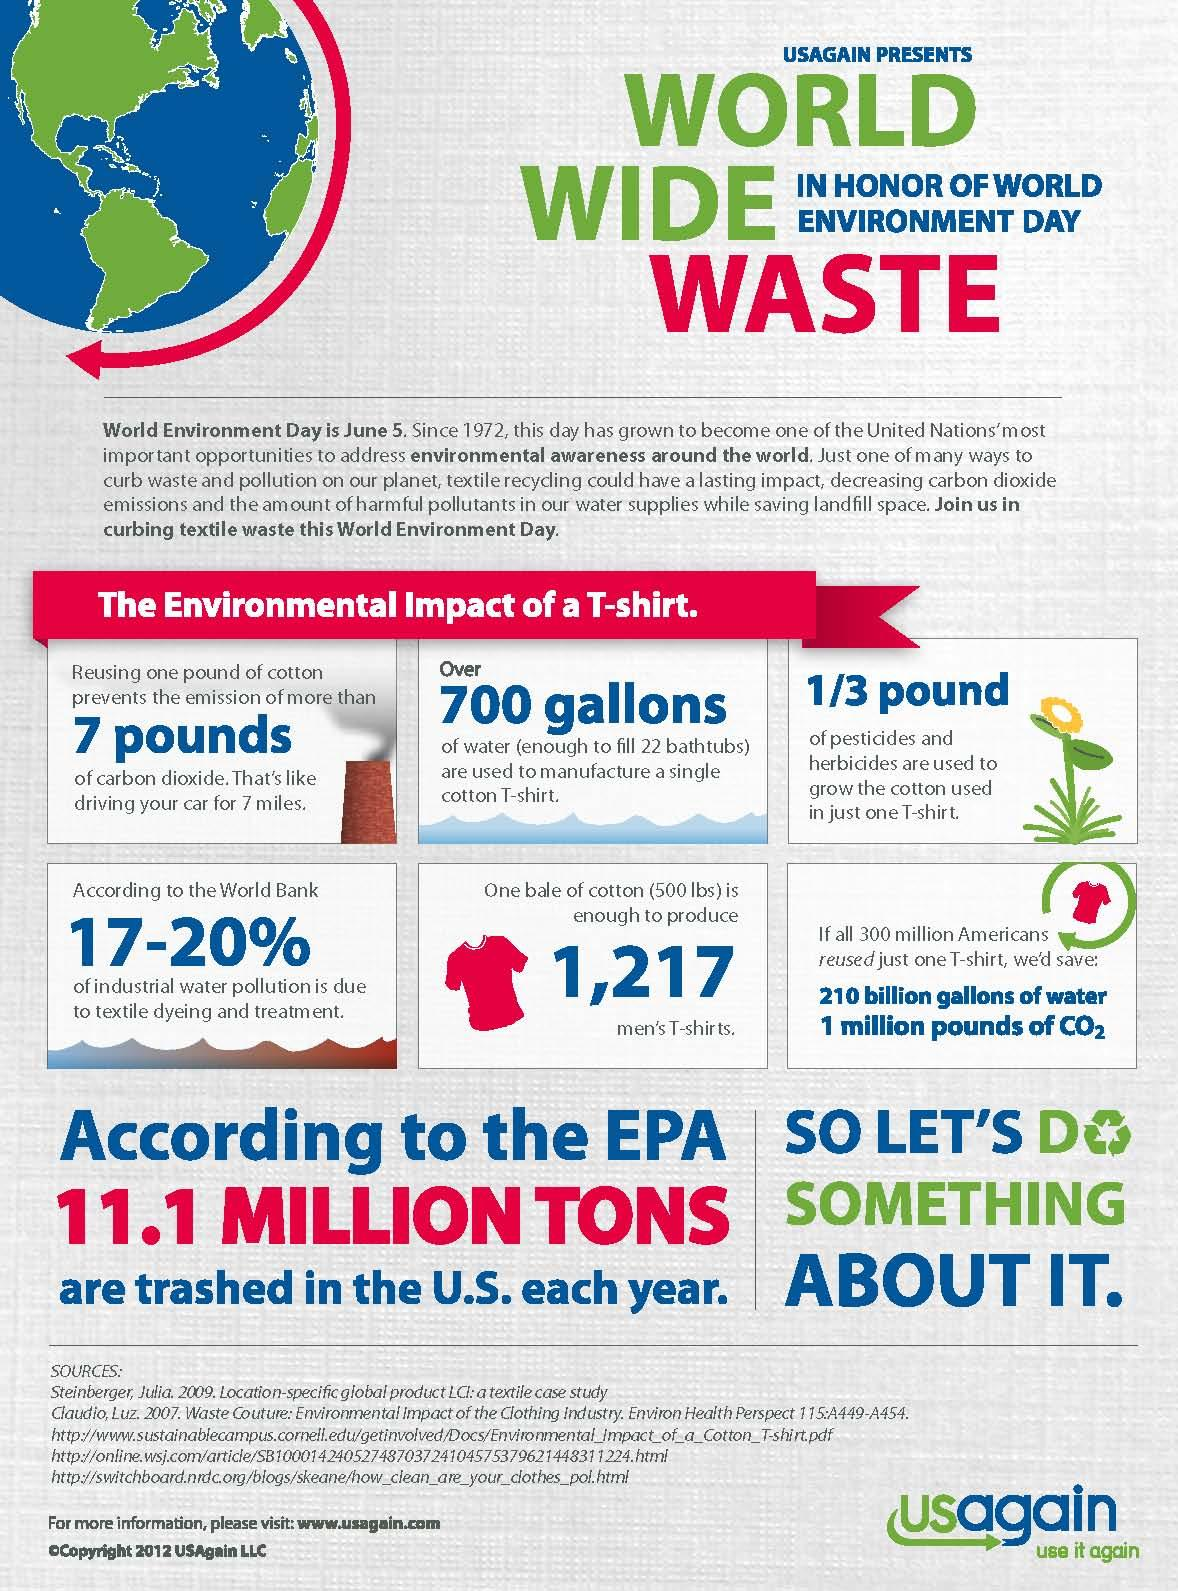Outline some significant characteristics in this image. One bale of cotton can produce 1,217 men's T-shirts. The production of a single cotton T-shirt requires 700 gallons of water, making it a significant contributor to water usage and pollution. The color of the T-shirt in the given infographic is blue, red, and yellow. The color of the T-shirt is red. 